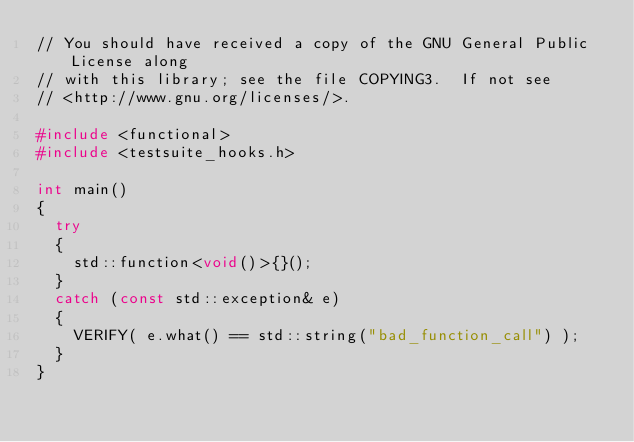Convert code to text. <code><loc_0><loc_0><loc_500><loc_500><_C++_>// You should have received a copy of the GNU General Public License along
// with this library; see the file COPYING3.  If not see
// <http://www.gnu.org/licenses/>.

#include <functional>
#include <testsuite_hooks.h>

int main()
{
  try
  {
    std::function<void()>{}();
  }
  catch (const std::exception& e)
  {
    VERIFY( e.what() == std::string("bad_function_call") );
  }
}
</code> 